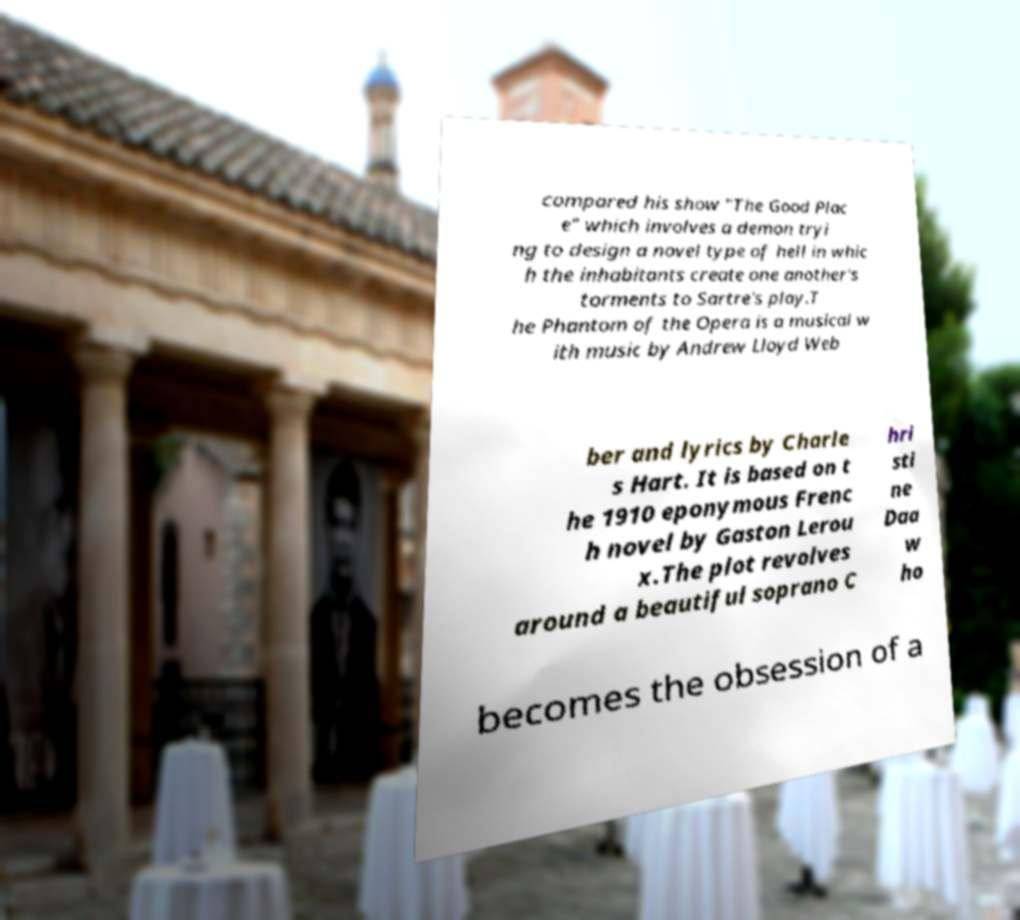Can you accurately transcribe the text from the provided image for me? compared his show "The Good Plac e" which involves a demon tryi ng to design a novel type of hell in whic h the inhabitants create one another's torments to Sartre's play.T he Phantom of the Opera is a musical w ith music by Andrew Lloyd Web ber and lyrics by Charle s Hart. It is based on t he 1910 eponymous Frenc h novel by Gaston Lerou x.The plot revolves around a beautiful soprano C hri sti ne Daa w ho becomes the obsession of a 